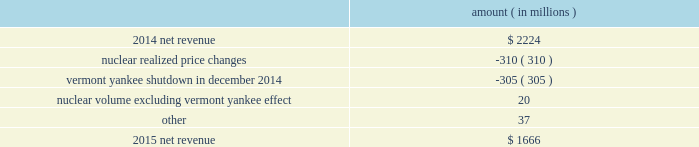Entergy corporation and subsidiaries management 2019s financial discussion and analysis the miso deferral variance is primarily due to the deferral in 2014 of non-fuel miso-related charges , as approved by the lpsc and the mpsc .
The deferral of non-fuel miso-related charges is partially offset in other operation and maintenance expenses .
See note 2 to the financial statements for further discussion of the recovery of non-fuel miso-related charges .
The waterford 3 replacement steam generator provision is due to a regulatory charge of approximately $ 32 million recorded in 2015 related to the uncertainty associated with the resolution of the waterford 3 replacement steam generator project .
See note 2 to the financial statements for a discussion of the waterford 3 replacement steam generator prudence review proceeding .
Entergy wholesale commodities following is an analysis of the change in net revenue comparing 2015 to 2014 .
Amount ( in millions ) .
As shown in the table above , net revenue for entergy wholesale commodities decreased by approximately $ 558 million in 2015 primarily due to : 2022 lower realized wholesale energy prices , primarily due to significantly higher northeast market power prices in 2014 , and lower capacity prices in 2015 ; and 2022 a decrease in net revenue as a result of vermont yankee ceasing power production in december 2014 .
The decrease was partially offset by higher volume in the entergy wholesale commodities nuclear fleet , excluding vermont yankee , resulting from fewer refueling outage days in 2015 as compared to 2014 , partially offset by more unplanned outage days in 2015 as compared to 2014. .
What percent of the decline in net revenue is attributed to the variance in nuclear realized price? 
Computations: (310 / 558)
Answer: 0.55556. 